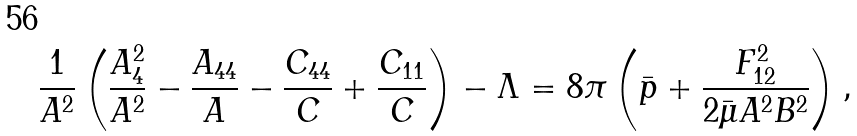Convert formula to latex. <formula><loc_0><loc_0><loc_500><loc_500>\frac { 1 } { A ^ { 2 } } \left ( \frac { A ^ { 2 } _ { 4 } } { A ^ { 2 } } - \frac { A _ { 4 4 } } { A } - \frac { C _ { 4 4 } } { C } + \frac { C _ { 1 1 } } { C } \right ) - \Lambda = 8 \pi \left ( \bar { p } + \frac { F ^ { 2 } _ { 1 2 } } { 2 \bar { \mu } A ^ { 2 } B ^ { 2 } } \right ) ,</formula> 